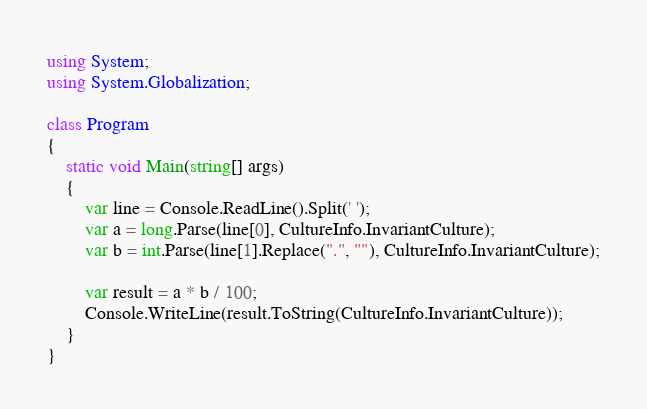Convert code to text. <code><loc_0><loc_0><loc_500><loc_500><_C#_>using System;
using System.Globalization;

class Program
{
    static void Main(string[] args)
    {
        var line = Console.ReadLine().Split(' ');
        var a = long.Parse(line[0], CultureInfo.InvariantCulture);
        var b = int.Parse(line[1].Replace(".", ""), CultureInfo.InvariantCulture);

        var result = a * b / 100;
        Console.WriteLine(result.ToString(CultureInfo.InvariantCulture));
    }
}
</code> 